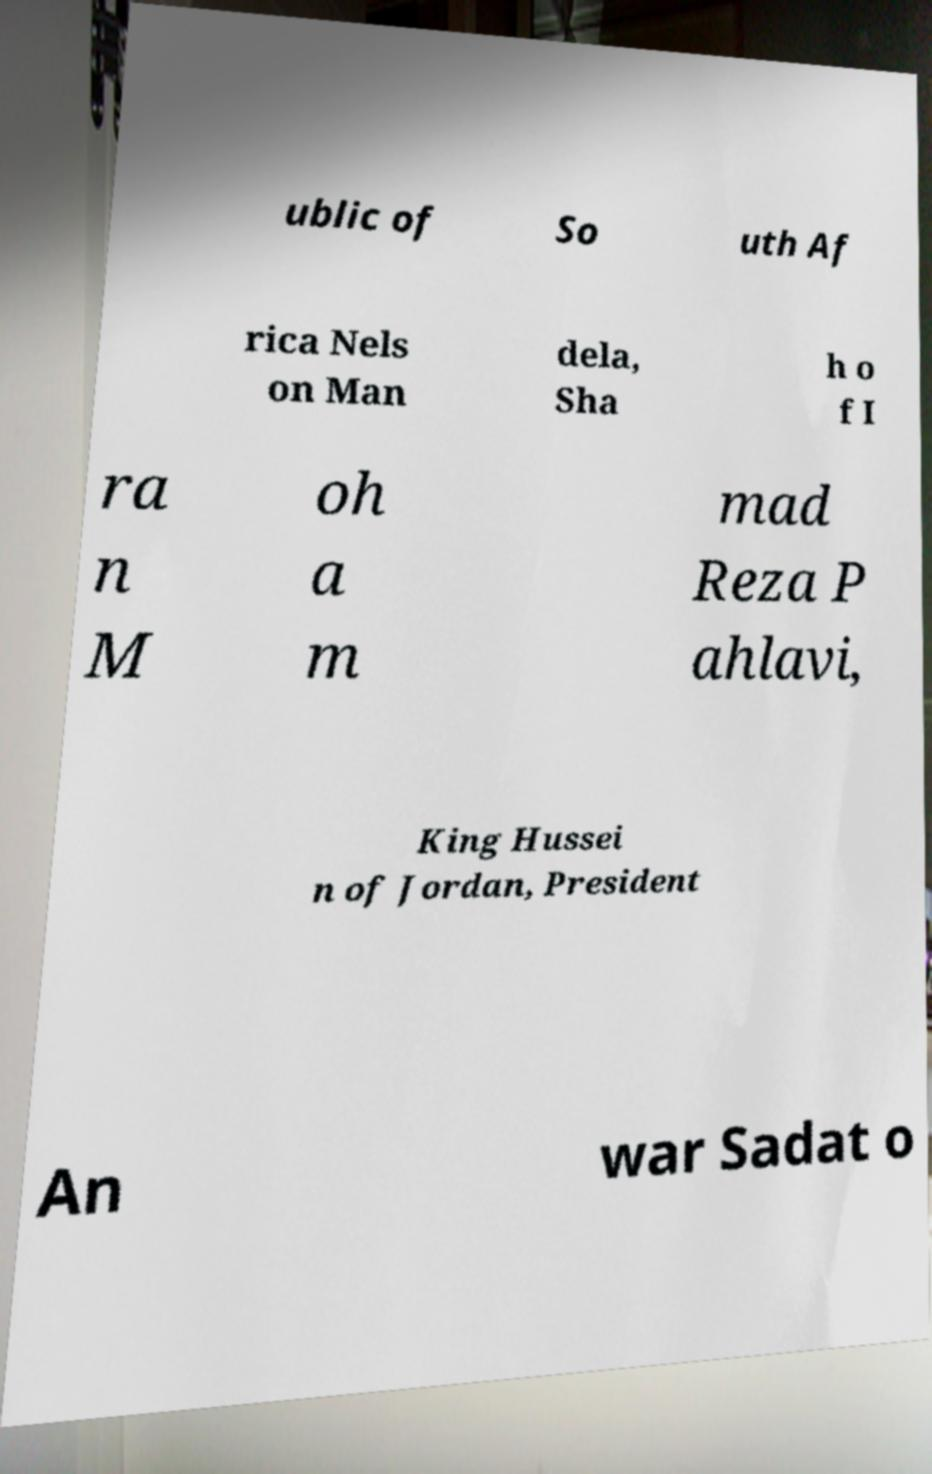Please read and relay the text visible in this image. What does it say? ublic of So uth Af rica Nels on Man dela, Sha h o f I ra n M oh a m mad Reza P ahlavi, King Hussei n of Jordan, President An war Sadat o 